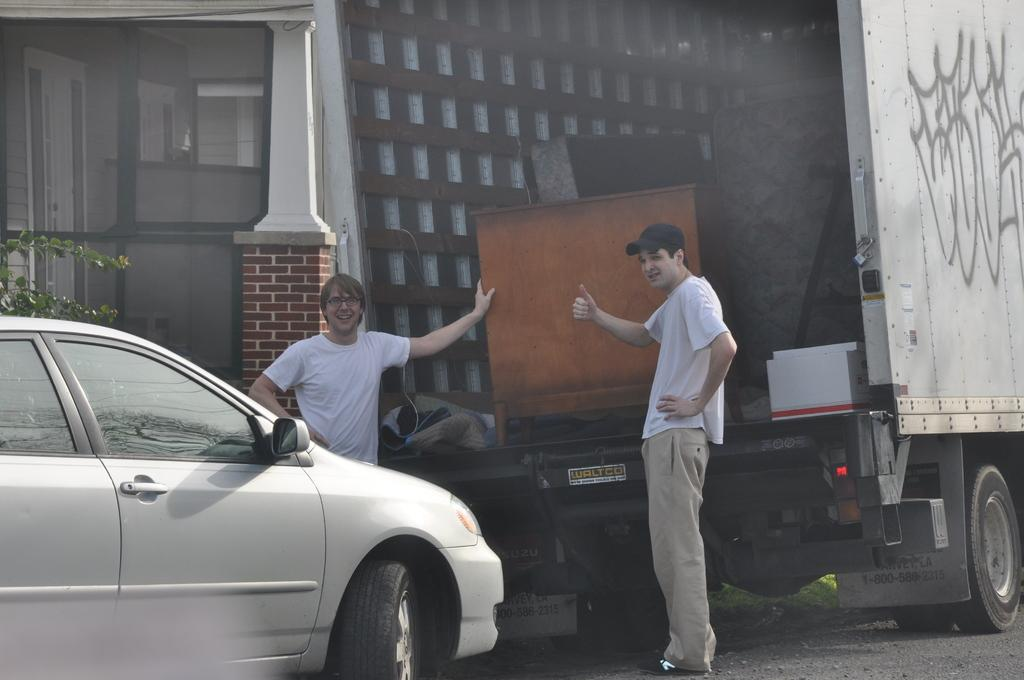How many people are in the image? There are two men in the image. What are the men doing in the image? The men are standing behind a truck. What other vehicle is visible in the image? There is a car on the road in the image. What can be seen in the distance behind the truck and car? There is a house in the background of the image. What type of agreement did the men sign in the image? There is no indication of an agreement or any signing activity in the image. 